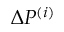<formula> <loc_0><loc_0><loc_500><loc_500>\Delta P ^ { ( i ) }</formula> 